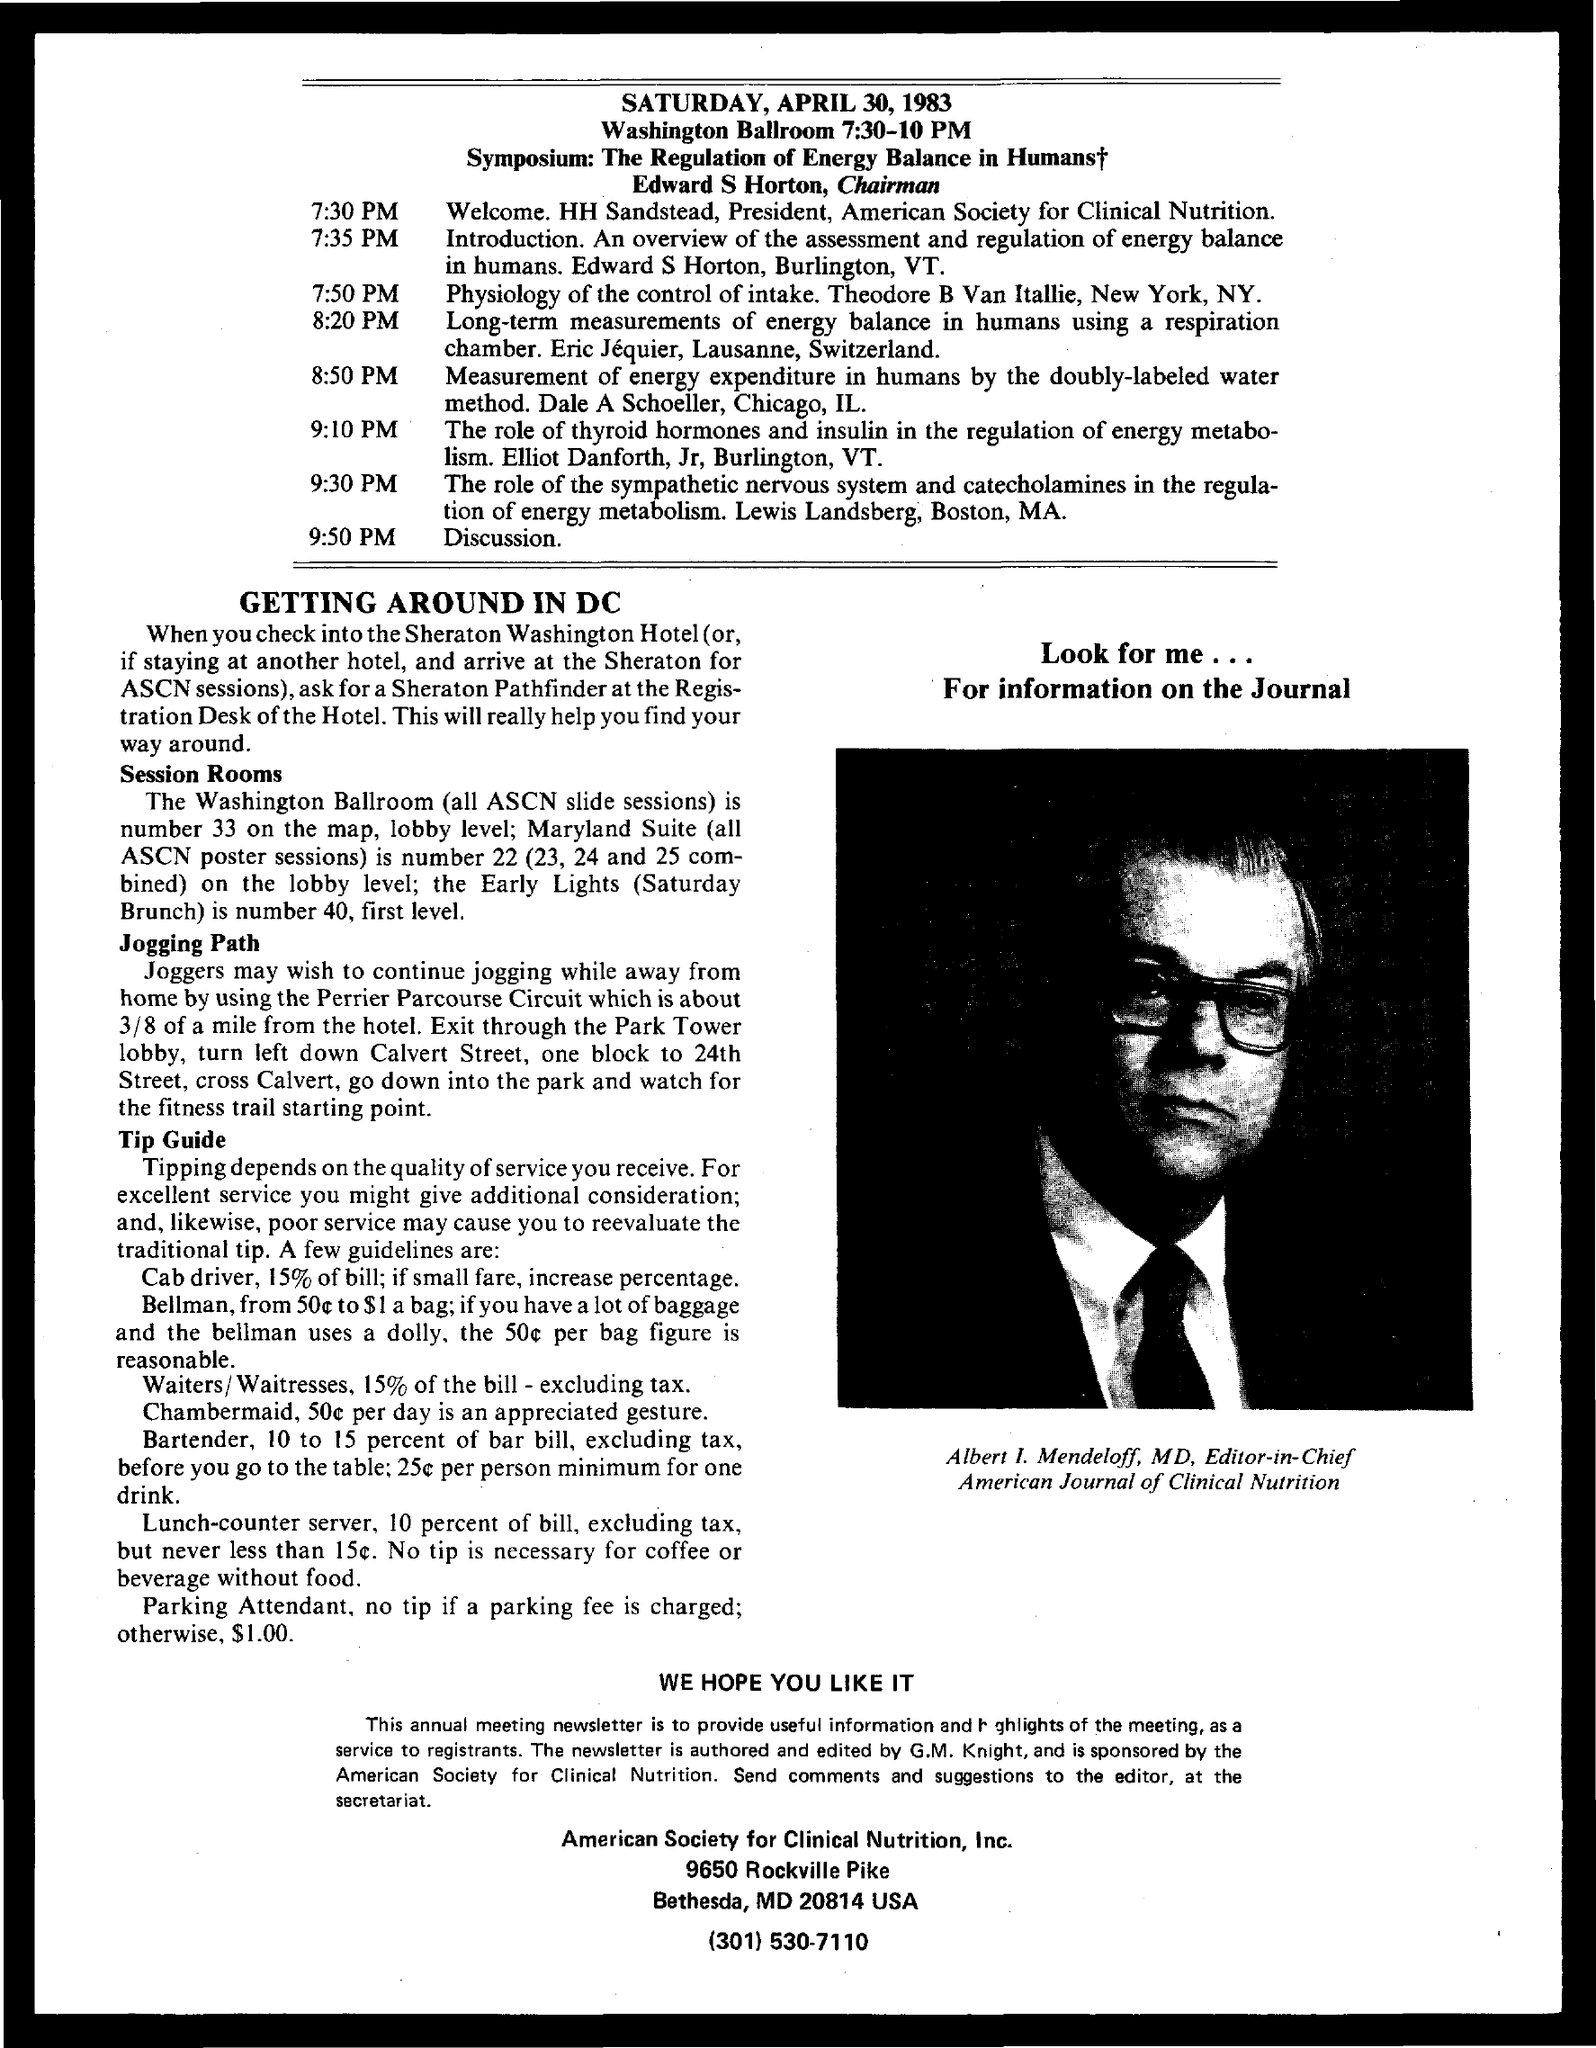Who is the MD of the American Journal of Clinical Nutrition?
Ensure brevity in your answer.  Albert I. Mendeloff. Who is the Editor-in-Chief of the American Journal of Clinical Nutrition?
Provide a short and direct response. Albert I. Mendeloff. What is the Washington ballroom number?
Your answer should be very brief. 33. 